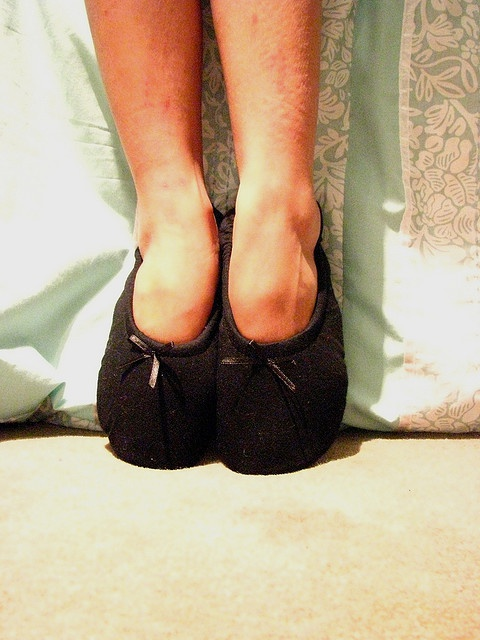Describe the objects in this image and their specific colors. I can see bed in ivory and tan tones and people in ivory, black, and tan tones in this image. 